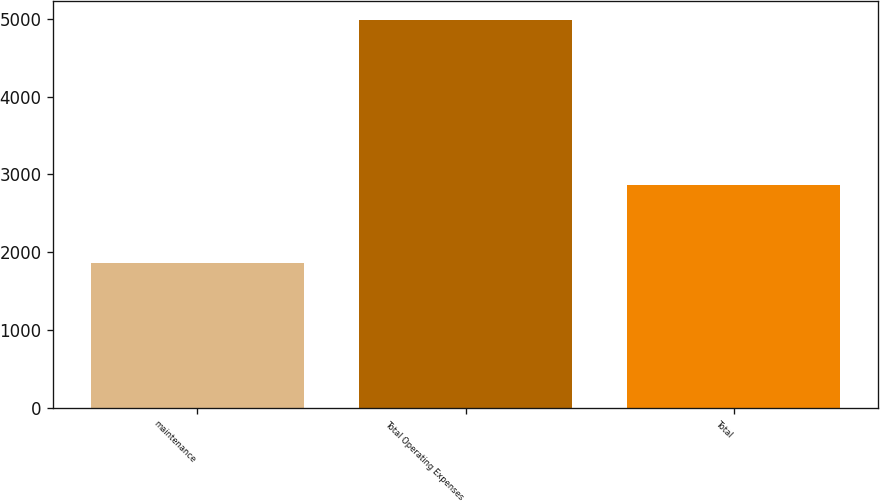Convert chart to OTSL. <chart><loc_0><loc_0><loc_500><loc_500><bar_chart><fcel>maintenance<fcel>Total Operating Expenses<fcel>Total<nl><fcel>1856<fcel>4985<fcel>2867<nl></chart> 